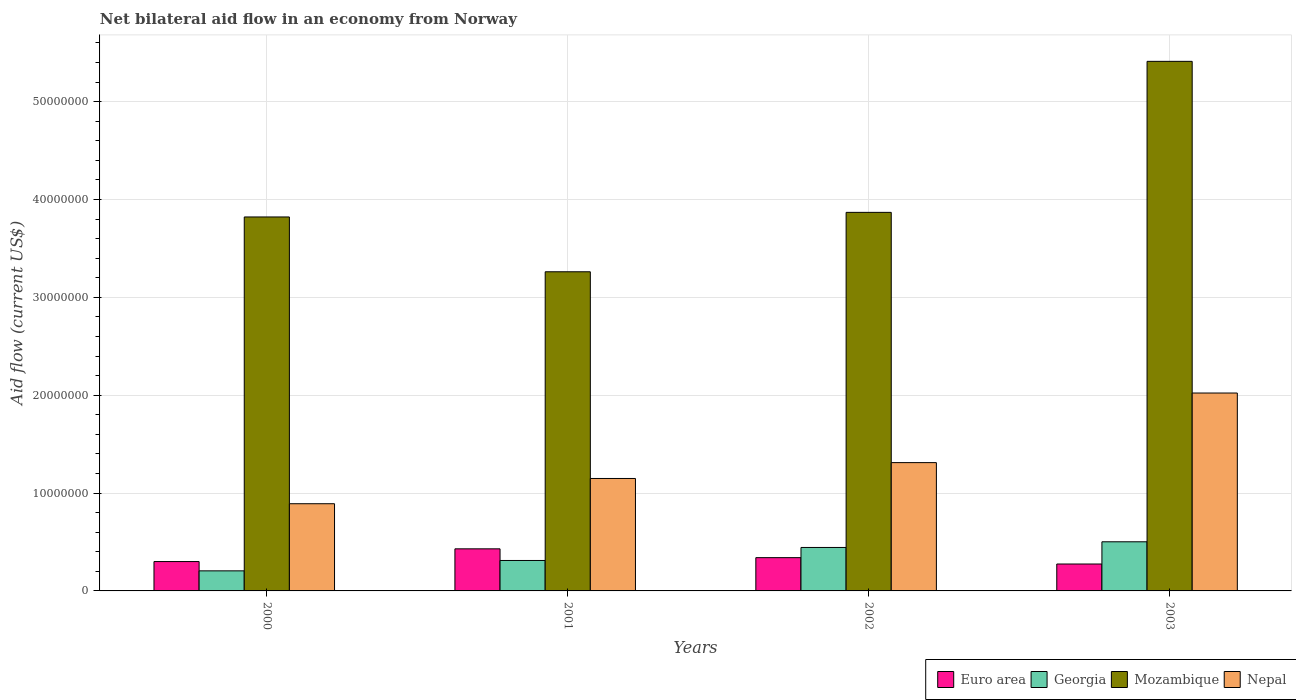Are the number of bars per tick equal to the number of legend labels?
Offer a terse response. Yes. Are the number of bars on each tick of the X-axis equal?
Keep it short and to the point. Yes. How many bars are there on the 3rd tick from the right?
Your answer should be very brief. 4. What is the net bilateral aid flow in Mozambique in 2002?
Offer a very short reply. 3.87e+07. Across all years, what is the maximum net bilateral aid flow in Georgia?
Keep it short and to the point. 5.02e+06. Across all years, what is the minimum net bilateral aid flow in Georgia?
Your answer should be very brief. 2.05e+06. In which year was the net bilateral aid flow in Georgia minimum?
Your answer should be very brief. 2000. What is the total net bilateral aid flow in Georgia in the graph?
Keep it short and to the point. 1.46e+07. What is the difference between the net bilateral aid flow in Euro area in 2000 and that in 2001?
Your response must be concise. -1.30e+06. What is the difference between the net bilateral aid flow in Mozambique in 2000 and the net bilateral aid flow in Euro area in 2001?
Offer a very short reply. 3.39e+07. What is the average net bilateral aid flow in Euro area per year?
Your response must be concise. 3.36e+06. In the year 2003, what is the difference between the net bilateral aid flow in Nepal and net bilateral aid flow in Euro area?
Provide a short and direct response. 1.75e+07. What is the ratio of the net bilateral aid flow in Mozambique in 2002 to that in 2003?
Make the answer very short. 0.71. What is the difference between the highest and the second highest net bilateral aid flow in Georgia?
Keep it short and to the point. 5.80e+05. What is the difference between the highest and the lowest net bilateral aid flow in Euro area?
Your answer should be very brief. 1.55e+06. In how many years, is the net bilateral aid flow in Euro area greater than the average net bilateral aid flow in Euro area taken over all years?
Provide a short and direct response. 2. Is it the case that in every year, the sum of the net bilateral aid flow in Nepal and net bilateral aid flow in Euro area is greater than the sum of net bilateral aid flow in Georgia and net bilateral aid flow in Mozambique?
Ensure brevity in your answer.  Yes. What does the 2nd bar from the left in 2001 represents?
Give a very brief answer. Georgia. How many bars are there?
Your answer should be compact. 16. What is the difference between two consecutive major ticks on the Y-axis?
Offer a very short reply. 1.00e+07. Are the values on the major ticks of Y-axis written in scientific E-notation?
Ensure brevity in your answer.  No. Does the graph contain grids?
Offer a very short reply. Yes. Where does the legend appear in the graph?
Keep it short and to the point. Bottom right. How many legend labels are there?
Your answer should be very brief. 4. What is the title of the graph?
Your answer should be very brief. Net bilateral aid flow in an economy from Norway. Does "French Polynesia" appear as one of the legend labels in the graph?
Ensure brevity in your answer.  No. What is the Aid flow (current US$) of Georgia in 2000?
Provide a succinct answer. 2.05e+06. What is the Aid flow (current US$) of Mozambique in 2000?
Keep it short and to the point. 3.82e+07. What is the Aid flow (current US$) in Nepal in 2000?
Give a very brief answer. 8.91e+06. What is the Aid flow (current US$) in Euro area in 2001?
Your response must be concise. 4.30e+06. What is the Aid flow (current US$) of Georgia in 2001?
Your answer should be very brief. 3.11e+06. What is the Aid flow (current US$) in Mozambique in 2001?
Offer a terse response. 3.26e+07. What is the Aid flow (current US$) of Nepal in 2001?
Provide a short and direct response. 1.15e+07. What is the Aid flow (current US$) of Euro area in 2002?
Ensure brevity in your answer.  3.40e+06. What is the Aid flow (current US$) in Georgia in 2002?
Make the answer very short. 4.44e+06. What is the Aid flow (current US$) of Mozambique in 2002?
Give a very brief answer. 3.87e+07. What is the Aid flow (current US$) of Nepal in 2002?
Your answer should be very brief. 1.31e+07. What is the Aid flow (current US$) of Euro area in 2003?
Provide a short and direct response. 2.75e+06. What is the Aid flow (current US$) of Georgia in 2003?
Your answer should be compact. 5.02e+06. What is the Aid flow (current US$) in Mozambique in 2003?
Keep it short and to the point. 5.41e+07. What is the Aid flow (current US$) in Nepal in 2003?
Keep it short and to the point. 2.02e+07. Across all years, what is the maximum Aid flow (current US$) of Euro area?
Give a very brief answer. 4.30e+06. Across all years, what is the maximum Aid flow (current US$) in Georgia?
Offer a terse response. 5.02e+06. Across all years, what is the maximum Aid flow (current US$) in Mozambique?
Your response must be concise. 5.41e+07. Across all years, what is the maximum Aid flow (current US$) of Nepal?
Ensure brevity in your answer.  2.02e+07. Across all years, what is the minimum Aid flow (current US$) of Euro area?
Provide a short and direct response. 2.75e+06. Across all years, what is the minimum Aid flow (current US$) of Georgia?
Your answer should be very brief. 2.05e+06. Across all years, what is the minimum Aid flow (current US$) in Mozambique?
Give a very brief answer. 3.26e+07. Across all years, what is the minimum Aid flow (current US$) of Nepal?
Your answer should be compact. 8.91e+06. What is the total Aid flow (current US$) in Euro area in the graph?
Provide a succinct answer. 1.34e+07. What is the total Aid flow (current US$) of Georgia in the graph?
Your response must be concise. 1.46e+07. What is the total Aid flow (current US$) of Mozambique in the graph?
Your response must be concise. 1.64e+08. What is the total Aid flow (current US$) of Nepal in the graph?
Ensure brevity in your answer.  5.37e+07. What is the difference between the Aid flow (current US$) in Euro area in 2000 and that in 2001?
Your answer should be very brief. -1.30e+06. What is the difference between the Aid flow (current US$) in Georgia in 2000 and that in 2001?
Your response must be concise. -1.06e+06. What is the difference between the Aid flow (current US$) of Mozambique in 2000 and that in 2001?
Offer a very short reply. 5.60e+06. What is the difference between the Aid flow (current US$) of Nepal in 2000 and that in 2001?
Offer a very short reply. -2.58e+06. What is the difference between the Aid flow (current US$) of Euro area in 2000 and that in 2002?
Your answer should be very brief. -4.00e+05. What is the difference between the Aid flow (current US$) of Georgia in 2000 and that in 2002?
Provide a succinct answer. -2.39e+06. What is the difference between the Aid flow (current US$) of Mozambique in 2000 and that in 2002?
Your answer should be very brief. -4.70e+05. What is the difference between the Aid flow (current US$) of Nepal in 2000 and that in 2002?
Keep it short and to the point. -4.20e+06. What is the difference between the Aid flow (current US$) of Euro area in 2000 and that in 2003?
Provide a short and direct response. 2.50e+05. What is the difference between the Aid flow (current US$) of Georgia in 2000 and that in 2003?
Offer a very short reply. -2.97e+06. What is the difference between the Aid flow (current US$) in Mozambique in 2000 and that in 2003?
Provide a short and direct response. -1.59e+07. What is the difference between the Aid flow (current US$) in Nepal in 2000 and that in 2003?
Your response must be concise. -1.13e+07. What is the difference between the Aid flow (current US$) of Euro area in 2001 and that in 2002?
Your answer should be very brief. 9.00e+05. What is the difference between the Aid flow (current US$) of Georgia in 2001 and that in 2002?
Provide a succinct answer. -1.33e+06. What is the difference between the Aid flow (current US$) in Mozambique in 2001 and that in 2002?
Offer a terse response. -6.07e+06. What is the difference between the Aid flow (current US$) in Nepal in 2001 and that in 2002?
Your answer should be compact. -1.62e+06. What is the difference between the Aid flow (current US$) in Euro area in 2001 and that in 2003?
Offer a terse response. 1.55e+06. What is the difference between the Aid flow (current US$) of Georgia in 2001 and that in 2003?
Make the answer very short. -1.91e+06. What is the difference between the Aid flow (current US$) of Mozambique in 2001 and that in 2003?
Provide a succinct answer. -2.15e+07. What is the difference between the Aid flow (current US$) in Nepal in 2001 and that in 2003?
Provide a succinct answer. -8.73e+06. What is the difference between the Aid flow (current US$) in Euro area in 2002 and that in 2003?
Give a very brief answer. 6.50e+05. What is the difference between the Aid flow (current US$) in Georgia in 2002 and that in 2003?
Your answer should be compact. -5.80e+05. What is the difference between the Aid flow (current US$) of Mozambique in 2002 and that in 2003?
Provide a short and direct response. -1.54e+07. What is the difference between the Aid flow (current US$) of Nepal in 2002 and that in 2003?
Offer a terse response. -7.11e+06. What is the difference between the Aid flow (current US$) of Euro area in 2000 and the Aid flow (current US$) of Mozambique in 2001?
Provide a short and direct response. -2.96e+07. What is the difference between the Aid flow (current US$) of Euro area in 2000 and the Aid flow (current US$) of Nepal in 2001?
Give a very brief answer. -8.49e+06. What is the difference between the Aid flow (current US$) of Georgia in 2000 and the Aid flow (current US$) of Mozambique in 2001?
Provide a succinct answer. -3.06e+07. What is the difference between the Aid flow (current US$) of Georgia in 2000 and the Aid flow (current US$) of Nepal in 2001?
Offer a very short reply. -9.44e+06. What is the difference between the Aid flow (current US$) in Mozambique in 2000 and the Aid flow (current US$) in Nepal in 2001?
Make the answer very short. 2.67e+07. What is the difference between the Aid flow (current US$) of Euro area in 2000 and the Aid flow (current US$) of Georgia in 2002?
Your answer should be very brief. -1.44e+06. What is the difference between the Aid flow (current US$) of Euro area in 2000 and the Aid flow (current US$) of Mozambique in 2002?
Offer a terse response. -3.57e+07. What is the difference between the Aid flow (current US$) of Euro area in 2000 and the Aid flow (current US$) of Nepal in 2002?
Give a very brief answer. -1.01e+07. What is the difference between the Aid flow (current US$) of Georgia in 2000 and the Aid flow (current US$) of Mozambique in 2002?
Make the answer very short. -3.66e+07. What is the difference between the Aid flow (current US$) in Georgia in 2000 and the Aid flow (current US$) in Nepal in 2002?
Your answer should be very brief. -1.11e+07. What is the difference between the Aid flow (current US$) of Mozambique in 2000 and the Aid flow (current US$) of Nepal in 2002?
Provide a succinct answer. 2.51e+07. What is the difference between the Aid flow (current US$) in Euro area in 2000 and the Aid flow (current US$) in Georgia in 2003?
Offer a very short reply. -2.02e+06. What is the difference between the Aid flow (current US$) of Euro area in 2000 and the Aid flow (current US$) of Mozambique in 2003?
Offer a terse response. -5.11e+07. What is the difference between the Aid flow (current US$) in Euro area in 2000 and the Aid flow (current US$) in Nepal in 2003?
Provide a succinct answer. -1.72e+07. What is the difference between the Aid flow (current US$) in Georgia in 2000 and the Aid flow (current US$) in Mozambique in 2003?
Give a very brief answer. -5.21e+07. What is the difference between the Aid flow (current US$) of Georgia in 2000 and the Aid flow (current US$) of Nepal in 2003?
Your response must be concise. -1.82e+07. What is the difference between the Aid flow (current US$) of Mozambique in 2000 and the Aid flow (current US$) of Nepal in 2003?
Offer a terse response. 1.80e+07. What is the difference between the Aid flow (current US$) of Euro area in 2001 and the Aid flow (current US$) of Mozambique in 2002?
Provide a short and direct response. -3.44e+07. What is the difference between the Aid flow (current US$) in Euro area in 2001 and the Aid flow (current US$) in Nepal in 2002?
Provide a short and direct response. -8.81e+06. What is the difference between the Aid flow (current US$) in Georgia in 2001 and the Aid flow (current US$) in Mozambique in 2002?
Provide a succinct answer. -3.56e+07. What is the difference between the Aid flow (current US$) of Georgia in 2001 and the Aid flow (current US$) of Nepal in 2002?
Offer a very short reply. -1.00e+07. What is the difference between the Aid flow (current US$) in Mozambique in 2001 and the Aid flow (current US$) in Nepal in 2002?
Give a very brief answer. 1.95e+07. What is the difference between the Aid flow (current US$) of Euro area in 2001 and the Aid flow (current US$) of Georgia in 2003?
Provide a succinct answer. -7.20e+05. What is the difference between the Aid flow (current US$) of Euro area in 2001 and the Aid flow (current US$) of Mozambique in 2003?
Make the answer very short. -4.98e+07. What is the difference between the Aid flow (current US$) in Euro area in 2001 and the Aid flow (current US$) in Nepal in 2003?
Your response must be concise. -1.59e+07. What is the difference between the Aid flow (current US$) in Georgia in 2001 and the Aid flow (current US$) in Mozambique in 2003?
Offer a terse response. -5.10e+07. What is the difference between the Aid flow (current US$) of Georgia in 2001 and the Aid flow (current US$) of Nepal in 2003?
Give a very brief answer. -1.71e+07. What is the difference between the Aid flow (current US$) of Mozambique in 2001 and the Aid flow (current US$) of Nepal in 2003?
Offer a terse response. 1.24e+07. What is the difference between the Aid flow (current US$) of Euro area in 2002 and the Aid flow (current US$) of Georgia in 2003?
Offer a terse response. -1.62e+06. What is the difference between the Aid flow (current US$) of Euro area in 2002 and the Aid flow (current US$) of Mozambique in 2003?
Give a very brief answer. -5.07e+07. What is the difference between the Aid flow (current US$) of Euro area in 2002 and the Aid flow (current US$) of Nepal in 2003?
Your response must be concise. -1.68e+07. What is the difference between the Aid flow (current US$) in Georgia in 2002 and the Aid flow (current US$) in Mozambique in 2003?
Keep it short and to the point. -4.97e+07. What is the difference between the Aid flow (current US$) of Georgia in 2002 and the Aid flow (current US$) of Nepal in 2003?
Provide a short and direct response. -1.58e+07. What is the difference between the Aid flow (current US$) of Mozambique in 2002 and the Aid flow (current US$) of Nepal in 2003?
Offer a very short reply. 1.85e+07. What is the average Aid flow (current US$) in Euro area per year?
Your response must be concise. 3.36e+06. What is the average Aid flow (current US$) in Georgia per year?
Make the answer very short. 3.66e+06. What is the average Aid flow (current US$) of Mozambique per year?
Keep it short and to the point. 4.09e+07. What is the average Aid flow (current US$) of Nepal per year?
Your answer should be compact. 1.34e+07. In the year 2000, what is the difference between the Aid flow (current US$) of Euro area and Aid flow (current US$) of Georgia?
Your answer should be very brief. 9.50e+05. In the year 2000, what is the difference between the Aid flow (current US$) of Euro area and Aid flow (current US$) of Mozambique?
Offer a terse response. -3.52e+07. In the year 2000, what is the difference between the Aid flow (current US$) of Euro area and Aid flow (current US$) of Nepal?
Give a very brief answer. -5.91e+06. In the year 2000, what is the difference between the Aid flow (current US$) in Georgia and Aid flow (current US$) in Mozambique?
Offer a terse response. -3.62e+07. In the year 2000, what is the difference between the Aid flow (current US$) of Georgia and Aid flow (current US$) of Nepal?
Your answer should be very brief. -6.86e+06. In the year 2000, what is the difference between the Aid flow (current US$) of Mozambique and Aid flow (current US$) of Nepal?
Ensure brevity in your answer.  2.93e+07. In the year 2001, what is the difference between the Aid flow (current US$) in Euro area and Aid flow (current US$) in Georgia?
Your answer should be compact. 1.19e+06. In the year 2001, what is the difference between the Aid flow (current US$) in Euro area and Aid flow (current US$) in Mozambique?
Give a very brief answer. -2.83e+07. In the year 2001, what is the difference between the Aid flow (current US$) in Euro area and Aid flow (current US$) in Nepal?
Give a very brief answer. -7.19e+06. In the year 2001, what is the difference between the Aid flow (current US$) of Georgia and Aid flow (current US$) of Mozambique?
Provide a short and direct response. -2.95e+07. In the year 2001, what is the difference between the Aid flow (current US$) in Georgia and Aid flow (current US$) in Nepal?
Keep it short and to the point. -8.38e+06. In the year 2001, what is the difference between the Aid flow (current US$) in Mozambique and Aid flow (current US$) in Nepal?
Offer a terse response. 2.11e+07. In the year 2002, what is the difference between the Aid flow (current US$) in Euro area and Aid flow (current US$) in Georgia?
Offer a terse response. -1.04e+06. In the year 2002, what is the difference between the Aid flow (current US$) of Euro area and Aid flow (current US$) of Mozambique?
Your response must be concise. -3.53e+07. In the year 2002, what is the difference between the Aid flow (current US$) in Euro area and Aid flow (current US$) in Nepal?
Give a very brief answer. -9.71e+06. In the year 2002, what is the difference between the Aid flow (current US$) of Georgia and Aid flow (current US$) of Mozambique?
Give a very brief answer. -3.42e+07. In the year 2002, what is the difference between the Aid flow (current US$) of Georgia and Aid flow (current US$) of Nepal?
Ensure brevity in your answer.  -8.67e+06. In the year 2002, what is the difference between the Aid flow (current US$) in Mozambique and Aid flow (current US$) in Nepal?
Make the answer very short. 2.56e+07. In the year 2003, what is the difference between the Aid flow (current US$) in Euro area and Aid flow (current US$) in Georgia?
Give a very brief answer. -2.27e+06. In the year 2003, what is the difference between the Aid flow (current US$) of Euro area and Aid flow (current US$) of Mozambique?
Keep it short and to the point. -5.14e+07. In the year 2003, what is the difference between the Aid flow (current US$) in Euro area and Aid flow (current US$) in Nepal?
Offer a very short reply. -1.75e+07. In the year 2003, what is the difference between the Aid flow (current US$) in Georgia and Aid flow (current US$) in Mozambique?
Give a very brief answer. -4.91e+07. In the year 2003, what is the difference between the Aid flow (current US$) in Georgia and Aid flow (current US$) in Nepal?
Provide a succinct answer. -1.52e+07. In the year 2003, what is the difference between the Aid flow (current US$) in Mozambique and Aid flow (current US$) in Nepal?
Your answer should be compact. 3.39e+07. What is the ratio of the Aid flow (current US$) of Euro area in 2000 to that in 2001?
Your answer should be compact. 0.7. What is the ratio of the Aid flow (current US$) in Georgia in 2000 to that in 2001?
Provide a succinct answer. 0.66. What is the ratio of the Aid flow (current US$) of Mozambique in 2000 to that in 2001?
Ensure brevity in your answer.  1.17. What is the ratio of the Aid flow (current US$) in Nepal in 2000 to that in 2001?
Your answer should be very brief. 0.78. What is the ratio of the Aid flow (current US$) in Euro area in 2000 to that in 2002?
Provide a short and direct response. 0.88. What is the ratio of the Aid flow (current US$) of Georgia in 2000 to that in 2002?
Provide a succinct answer. 0.46. What is the ratio of the Aid flow (current US$) in Mozambique in 2000 to that in 2002?
Provide a short and direct response. 0.99. What is the ratio of the Aid flow (current US$) in Nepal in 2000 to that in 2002?
Keep it short and to the point. 0.68. What is the ratio of the Aid flow (current US$) of Georgia in 2000 to that in 2003?
Your answer should be very brief. 0.41. What is the ratio of the Aid flow (current US$) in Mozambique in 2000 to that in 2003?
Keep it short and to the point. 0.71. What is the ratio of the Aid flow (current US$) in Nepal in 2000 to that in 2003?
Offer a very short reply. 0.44. What is the ratio of the Aid flow (current US$) of Euro area in 2001 to that in 2002?
Give a very brief answer. 1.26. What is the ratio of the Aid flow (current US$) of Georgia in 2001 to that in 2002?
Provide a short and direct response. 0.7. What is the ratio of the Aid flow (current US$) in Mozambique in 2001 to that in 2002?
Give a very brief answer. 0.84. What is the ratio of the Aid flow (current US$) in Nepal in 2001 to that in 2002?
Ensure brevity in your answer.  0.88. What is the ratio of the Aid flow (current US$) in Euro area in 2001 to that in 2003?
Give a very brief answer. 1.56. What is the ratio of the Aid flow (current US$) in Georgia in 2001 to that in 2003?
Provide a succinct answer. 0.62. What is the ratio of the Aid flow (current US$) of Mozambique in 2001 to that in 2003?
Ensure brevity in your answer.  0.6. What is the ratio of the Aid flow (current US$) in Nepal in 2001 to that in 2003?
Make the answer very short. 0.57. What is the ratio of the Aid flow (current US$) of Euro area in 2002 to that in 2003?
Your answer should be very brief. 1.24. What is the ratio of the Aid flow (current US$) in Georgia in 2002 to that in 2003?
Make the answer very short. 0.88. What is the ratio of the Aid flow (current US$) of Mozambique in 2002 to that in 2003?
Keep it short and to the point. 0.71. What is the ratio of the Aid flow (current US$) in Nepal in 2002 to that in 2003?
Your answer should be compact. 0.65. What is the difference between the highest and the second highest Aid flow (current US$) of Euro area?
Offer a terse response. 9.00e+05. What is the difference between the highest and the second highest Aid flow (current US$) of Georgia?
Provide a short and direct response. 5.80e+05. What is the difference between the highest and the second highest Aid flow (current US$) of Mozambique?
Offer a terse response. 1.54e+07. What is the difference between the highest and the second highest Aid flow (current US$) of Nepal?
Provide a succinct answer. 7.11e+06. What is the difference between the highest and the lowest Aid flow (current US$) in Euro area?
Ensure brevity in your answer.  1.55e+06. What is the difference between the highest and the lowest Aid flow (current US$) of Georgia?
Your answer should be compact. 2.97e+06. What is the difference between the highest and the lowest Aid flow (current US$) in Mozambique?
Offer a very short reply. 2.15e+07. What is the difference between the highest and the lowest Aid flow (current US$) in Nepal?
Your response must be concise. 1.13e+07. 